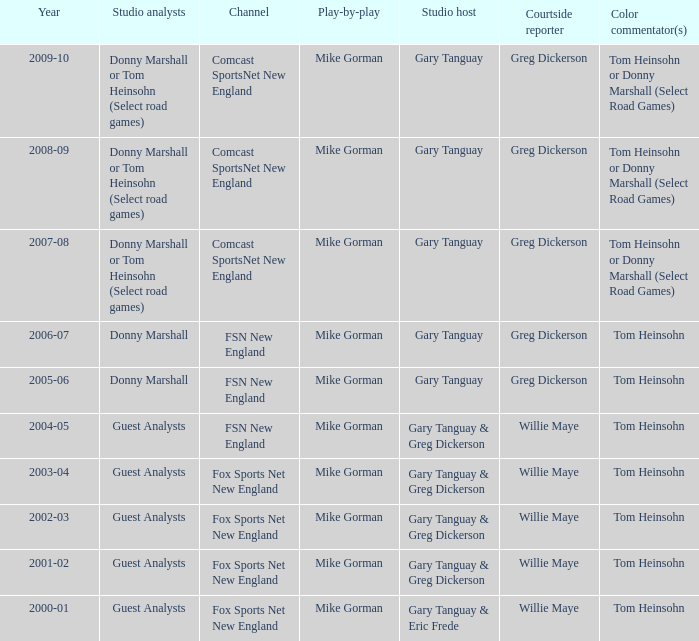WHich Studio host has a Year of 2003-04? Gary Tanguay & Greg Dickerson. 